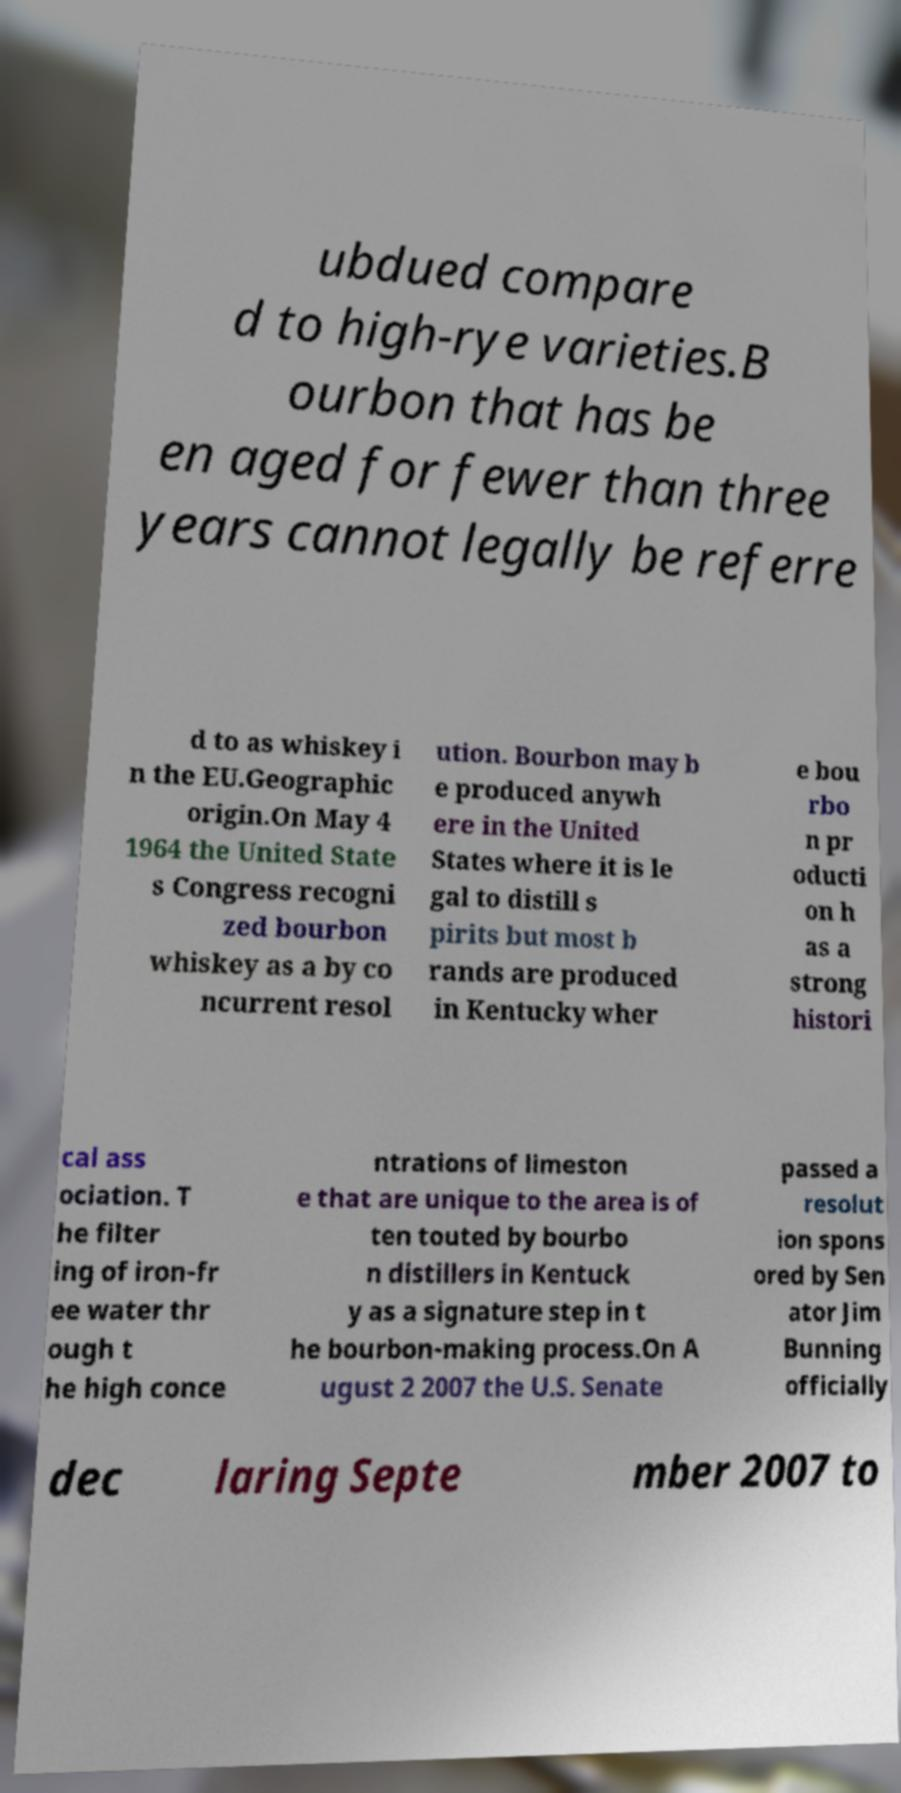Can you read and provide the text displayed in the image?This photo seems to have some interesting text. Can you extract and type it out for me? ubdued compare d to high-rye varieties.B ourbon that has be en aged for fewer than three years cannot legally be referre d to as whiskey i n the EU.Geographic origin.On May 4 1964 the United State s Congress recogni zed bourbon whiskey as a by co ncurrent resol ution. Bourbon may b e produced anywh ere in the United States where it is le gal to distill s pirits but most b rands are produced in Kentucky wher e bou rbo n pr oducti on h as a strong histori cal ass ociation. T he filter ing of iron-fr ee water thr ough t he high conce ntrations of limeston e that are unique to the area is of ten touted by bourbo n distillers in Kentuck y as a signature step in t he bourbon-making process.On A ugust 2 2007 the U.S. Senate passed a resolut ion spons ored by Sen ator Jim Bunning officially dec laring Septe mber 2007 to 